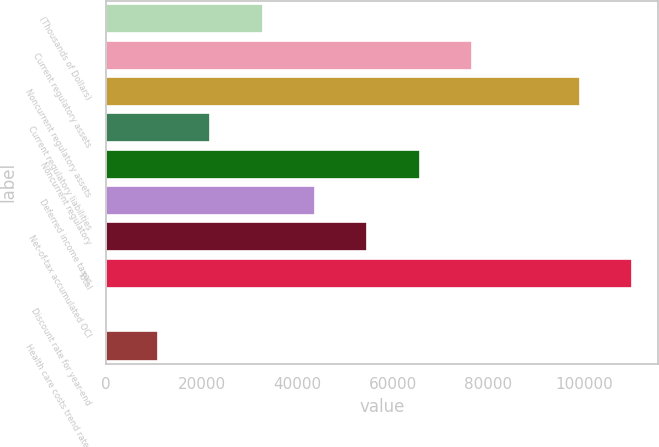Convert chart. <chart><loc_0><loc_0><loc_500><loc_500><bar_chart><fcel>(Thousands of Dollars)<fcel>Current regulatory assets<fcel>Noncurrent regulatory assets<fcel>Current regulatory liabilities<fcel>Noncurrent regulatory<fcel>Deferred income taxes<fcel>Net-of-tax accumulated OCI<fcel>Total<fcel>Discount rate for year-end<fcel>Health care costs trend rate -<nl><fcel>32803.6<fcel>76535.3<fcel>99071<fcel>21870.7<fcel>65602.3<fcel>43736.5<fcel>54669.4<fcel>110004<fcel>4.82<fcel>10937.7<nl></chart> 